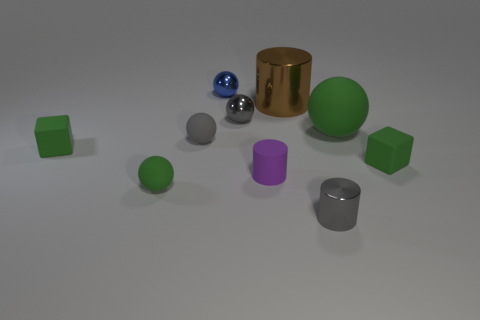Are there any large green spheres that are on the right side of the tiny cylinder behind the matte thing in front of the small purple matte thing?
Your answer should be compact. Yes. What is the color of the big matte thing?
Ensure brevity in your answer.  Green. There is a tiny green rubber thing that is to the right of the tiny green rubber ball; is its shape the same as the big green matte object?
Keep it short and to the point. No. What number of objects are tiny objects or tiny gray things that are to the left of the small blue metal object?
Provide a short and direct response. 8. Do the ball right of the large metallic thing and the small purple thing have the same material?
Make the answer very short. Yes. What material is the small green cube to the right of the small gray shiny object that is in front of the tiny gray metal ball?
Provide a succinct answer. Rubber. Are there more small gray metallic spheres that are in front of the small purple matte cylinder than large green spheres behind the brown cylinder?
Offer a terse response. No. The blue sphere has what size?
Your answer should be compact. Small. Does the small matte block that is on the right side of the blue metallic object have the same color as the big matte object?
Your answer should be compact. Yes. Is there a tiny green matte block to the right of the large object in front of the large shiny cylinder?
Your response must be concise. Yes. 